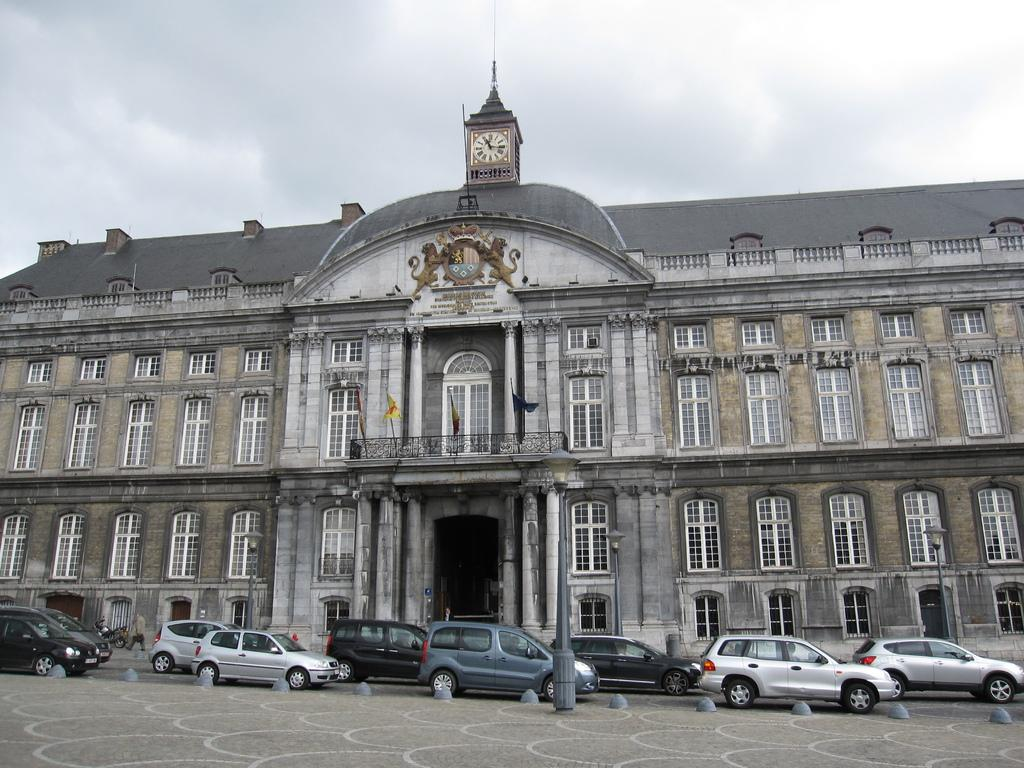What type of structure is present in the image? There is a building in the image. What feature can be seen on the building? The building has windows. What additional objects are present in the image? There are flags, light poles, vehicles, and a person walking in the image. What is the color of the sky in the image? The sky is blue and white in color. Can you see a rake being used by the person walking in the image? No, there is no rake present in the image. Is there a carriage visible in the image? No, there is no carriage present in the image. 